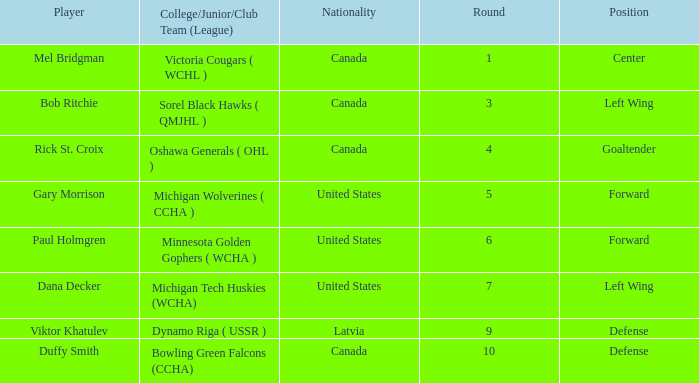Which Player has United States as Nationality, forward as Position and a greater than 5 Round? Paul Holmgren. 